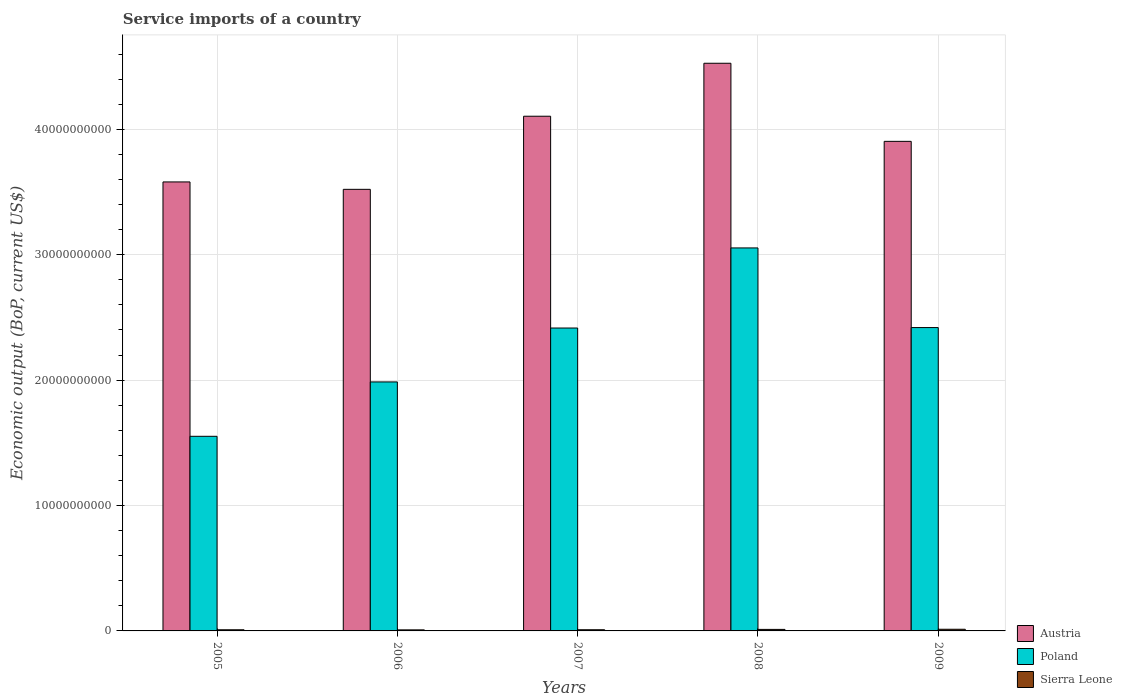How many different coloured bars are there?
Offer a very short reply. 3. How many groups of bars are there?
Ensure brevity in your answer.  5. Are the number of bars per tick equal to the number of legend labels?
Give a very brief answer. Yes. Are the number of bars on each tick of the X-axis equal?
Keep it short and to the point. Yes. In how many cases, is the number of bars for a given year not equal to the number of legend labels?
Ensure brevity in your answer.  0. What is the service imports in Poland in 2006?
Offer a terse response. 1.99e+1. Across all years, what is the maximum service imports in Sierra Leone?
Offer a terse response. 1.32e+08. Across all years, what is the minimum service imports in Sierra Leone?
Your answer should be compact. 8.40e+07. In which year was the service imports in Austria maximum?
Your answer should be compact. 2008. In which year was the service imports in Poland minimum?
Your answer should be compact. 2005. What is the total service imports in Austria in the graph?
Ensure brevity in your answer.  1.96e+11. What is the difference between the service imports in Poland in 2005 and that in 2009?
Provide a short and direct response. -8.67e+09. What is the difference between the service imports in Poland in 2009 and the service imports in Sierra Leone in 2006?
Your answer should be very brief. 2.41e+1. What is the average service imports in Poland per year?
Make the answer very short. 2.29e+1. In the year 2008, what is the difference between the service imports in Sierra Leone and service imports in Poland?
Provide a succinct answer. -3.04e+1. What is the ratio of the service imports in Poland in 2006 to that in 2007?
Offer a very short reply. 0.82. Is the difference between the service imports in Sierra Leone in 2006 and 2009 greater than the difference between the service imports in Poland in 2006 and 2009?
Your answer should be compact. Yes. What is the difference between the highest and the second highest service imports in Sierra Leone?
Make the answer very short. 1.11e+07. What is the difference between the highest and the lowest service imports in Poland?
Your response must be concise. 1.50e+1. In how many years, is the service imports in Poland greater than the average service imports in Poland taken over all years?
Give a very brief answer. 3. What does the 2nd bar from the left in 2005 represents?
Your answer should be compact. Poland. What does the 2nd bar from the right in 2007 represents?
Offer a very short reply. Poland. Is it the case that in every year, the sum of the service imports in Austria and service imports in Sierra Leone is greater than the service imports in Poland?
Your answer should be compact. Yes. How many bars are there?
Give a very brief answer. 15. How many years are there in the graph?
Provide a succinct answer. 5. Are the values on the major ticks of Y-axis written in scientific E-notation?
Offer a terse response. No. Does the graph contain any zero values?
Ensure brevity in your answer.  No. Does the graph contain grids?
Give a very brief answer. Yes. How many legend labels are there?
Ensure brevity in your answer.  3. What is the title of the graph?
Offer a very short reply. Service imports of a country. What is the label or title of the X-axis?
Your answer should be compact. Years. What is the label or title of the Y-axis?
Offer a terse response. Economic output (BoP, current US$). What is the Economic output (BoP, current US$) in Austria in 2005?
Provide a short and direct response. 3.58e+1. What is the Economic output (BoP, current US$) in Poland in 2005?
Your answer should be very brief. 1.55e+1. What is the Economic output (BoP, current US$) of Sierra Leone in 2005?
Your answer should be very brief. 9.14e+07. What is the Economic output (BoP, current US$) of Austria in 2006?
Keep it short and to the point. 3.52e+1. What is the Economic output (BoP, current US$) in Poland in 2006?
Offer a very short reply. 1.99e+1. What is the Economic output (BoP, current US$) of Sierra Leone in 2006?
Provide a succinct answer. 8.40e+07. What is the Economic output (BoP, current US$) of Austria in 2007?
Your answer should be very brief. 4.10e+1. What is the Economic output (BoP, current US$) of Poland in 2007?
Your response must be concise. 2.42e+1. What is the Economic output (BoP, current US$) in Sierra Leone in 2007?
Your answer should be very brief. 9.43e+07. What is the Economic output (BoP, current US$) of Austria in 2008?
Provide a short and direct response. 4.53e+1. What is the Economic output (BoP, current US$) of Poland in 2008?
Ensure brevity in your answer.  3.05e+1. What is the Economic output (BoP, current US$) of Sierra Leone in 2008?
Make the answer very short. 1.21e+08. What is the Economic output (BoP, current US$) of Austria in 2009?
Give a very brief answer. 3.90e+1. What is the Economic output (BoP, current US$) in Poland in 2009?
Offer a very short reply. 2.42e+1. What is the Economic output (BoP, current US$) of Sierra Leone in 2009?
Your answer should be very brief. 1.32e+08. Across all years, what is the maximum Economic output (BoP, current US$) of Austria?
Provide a succinct answer. 4.53e+1. Across all years, what is the maximum Economic output (BoP, current US$) of Poland?
Ensure brevity in your answer.  3.05e+1. Across all years, what is the maximum Economic output (BoP, current US$) of Sierra Leone?
Provide a short and direct response. 1.32e+08. Across all years, what is the minimum Economic output (BoP, current US$) in Austria?
Make the answer very short. 3.52e+1. Across all years, what is the minimum Economic output (BoP, current US$) in Poland?
Offer a terse response. 1.55e+1. Across all years, what is the minimum Economic output (BoP, current US$) in Sierra Leone?
Offer a very short reply. 8.40e+07. What is the total Economic output (BoP, current US$) in Austria in the graph?
Keep it short and to the point. 1.96e+11. What is the total Economic output (BoP, current US$) of Poland in the graph?
Your answer should be compact. 1.14e+11. What is the total Economic output (BoP, current US$) of Sierra Leone in the graph?
Make the answer very short. 5.23e+08. What is the difference between the Economic output (BoP, current US$) of Austria in 2005 and that in 2006?
Offer a terse response. 5.90e+08. What is the difference between the Economic output (BoP, current US$) of Poland in 2005 and that in 2006?
Your answer should be very brief. -4.34e+09. What is the difference between the Economic output (BoP, current US$) of Sierra Leone in 2005 and that in 2006?
Give a very brief answer. 7.37e+06. What is the difference between the Economic output (BoP, current US$) in Austria in 2005 and that in 2007?
Give a very brief answer. -5.24e+09. What is the difference between the Economic output (BoP, current US$) in Poland in 2005 and that in 2007?
Offer a terse response. -8.64e+09. What is the difference between the Economic output (BoP, current US$) in Sierra Leone in 2005 and that in 2007?
Offer a terse response. -2.94e+06. What is the difference between the Economic output (BoP, current US$) in Austria in 2005 and that in 2008?
Your answer should be very brief. -9.46e+09. What is the difference between the Economic output (BoP, current US$) in Poland in 2005 and that in 2008?
Make the answer very short. -1.50e+1. What is the difference between the Economic output (BoP, current US$) in Sierra Leone in 2005 and that in 2008?
Your answer should be very brief. -2.96e+07. What is the difference between the Economic output (BoP, current US$) in Austria in 2005 and that in 2009?
Ensure brevity in your answer.  -3.24e+09. What is the difference between the Economic output (BoP, current US$) of Poland in 2005 and that in 2009?
Ensure brevity in your answer.  -8.67e+09. What is the difference between the Economic output (BoP, current US$) of Sierra Leone in 2005 and that in 2009?
Provide a succinct answer. -4.07e+07. What is the difference between the Economic output (BoP, current US$) in Austria in 2006 and that in 2007?
Provide a short and direct response. -5.83e+09. What is the difference between the Economic output (BoP, current US$) in Poland in 2006 and that in 2007?
Offer a very short reply. -4.30e+09. What is the difference between the Economic output (BoP, current US$) in Sierra Leone in 2006 and that in 2007?
Your answer should be very brief. -1.03e+07. What is the difference between the Economic output (BoP, current US$) of Austria in 2006 and that in 2008?
Provide a succinct answer. -1.01e+1. What is the difference between the Economic output (BoP, current US$) in Poland in 2006 and that in 2008?
Provide a short and direct response. -1.07e+1. What is the difference between the Economic output (BoP, current US$) in Sierra Leone in 2006 and that in 2008?
Provide a short and direct response. -3.70e+07. What is the difference between the Economic output (BoP, current US$) in Austria in 2006 and that in 2009?
Keep it short and to the point. -3.83e+09. What is the difference between the Economic output (BoP, current US$) in Poland in 2006 and that in 2009?
Your answer should be very brief. -4.34e+09. What is the difference between the Economic output (BoP, current US$) of Sierra Leone in 2006 and that in 2009?
Ensure brevity in your answer.  -4.81e+07. What is the difference between the Economic output (BoP, current US$) in Austria in 2007 and that in 2008?
Provide a succinct answer. -4.22e+09. What is the difference between the Economic output (BoP, current US$) of Poland in 2007 and that in 2008?
Ensure brevity in your answer.  -6.39e+09. What is the difference between the Economic output (BoP, current US$) of Sierra Leone in 2007 and that in 2008?
Offer a very short reply. -2.66e+07. What is the difference between the Economic output (BoP, current US$) of Austria in 2007 and that in 2009?
Offer a very short reply. 2.00e+09. What is the difference between the Economic output (BoP, current US$) of Poland in 2007 and that in 2009?
Provide a succinct answer. -3.50e+07. What is the difference between the Economic output (BoP, current US$) of Sierra Leone in 2007 and that in 2009?
Your answer should be very brief. -3.78e+07. What is the difference between the Economic output (BoP, current US$) in Austria in 2008 and that in 2009?
Make the answer very short. 6.23e+09. What is the difference between the Economic output (BoP, current US$) of Poland in 2008 and that in 2009?
Provide a succinct answer. 6.35e+09. What is the difference between the Economic output (BoP, current US$) of Sierra Leone in 2008 and that in 2009?
Provide a short and direct response. -1.11e+07. What is the difference between the Economic output (BoP, current US$) in Austria in 2005 and the Economic output (BoP, current US$) in Poland in 2006?
Your answer should be very brief. 1.59e+1. What is the difference between the Economic output (BoP, current US$) in Austria in 2005 and the Economic output (BoP, current US$) in Sierra Leone in 2006?
Provide a short and direct response. 3.57e+1. What is the difference between the Economic output (BoP, current US$) of Poland in 2005 and the Economic output (BoP, current US$) of Sierra Leone in 2006?
Provide a succinct answer. 1.54e+1. What is the difference between the Economic output (BoP, current US$) of Austria in 2005 and the Economic output (BoP, current US$) of Poland in 2007?
Ensure brevity in your answer.  1.16e+1. What is the difference between the Economic output (BoP, current US$) in Austria in 2005 and the Economic output (BoP, current US$) in Sierra Leone in 2007?
Your response must be concise. 3.57e+1. What is the difference between the Economic output (BoP, current US$) of Poland in 2005 and the Economic output (BoP, current US$) of Sierra Leone in 2007?
Make the answer very short. 1.54e+1. What is the difference between the Economic output (BoP, current US$) of Austria in 2005 and the Economic output (BoP, current US$) of Poland in 2008?
Keep it short and to the point. 5.26e+09. What is the difference between the Economic output (BoP, current US$) of Austria in 2005 and the Economic output (BoP, current US$) of Sierra Leone in 2008?
Provide a succinct answer. 3.57e+1. What is the difference between the Economic output (BoP, current US$) of Poland in 2005 and the Economic output (BoP, current US$) of Sierra Leone in 2008?
Your response must be concise. 1.54e+1. What is the difference between the Economic output (BoP, current US$) in Austria in 2005 and the Economic output (BoP, current US$) in Poland in 2009?
Ensure brevity in your answer.  1.16e+1. What is the difference between the Economic output (BoP, current US$) in Austria in 2005 and the Economic output (BoP, current US$) in Sierra Leone in 2009?
Offer a very short reply. 3.57e+1. What is the difference between the Economic output (BoP, current US$) of Poland in 2005 and the Economic output (BoP, current US$) of Sierra Leone in 2009?
Keep it short and to the point. 1.54e+1. What is the difference between the Economic output (BoP, current US$) of Austria in 2006 and the Economic output (BoP, current US$) of Poland in 2007?
Provide a succinct answer. 1.11e+1. What is the difference between the Economic output (BoP, current US$) of Austria in 2006 and the Economic output (BoP, current US$) of Sierra Leone in 2007?
Offer a terse response. 3.51e+1. What is the difference between the Economic output (BoP, current US$) of Poland in 2006 and the Economic output (BoP, current US$) of Sierra Leone in 2007?
Offer a terse response. 1.98e+1. What is the difference between the Economic output (BoP, current US$) in Austria in 2006 and the Economic output (BoP, current US$) in Poland in 2008?
Offer a very short reply. 4.67e+09. What is the difference between the Economic output (BoP, current US$) of Austria in 2006 and the Economic output (BoP, current US$) of Sierra Leone in 2008?
Your answer should be very brief. 3.51e+1. What is the difference between the Economic output (BoP, current US$) of Poland in 2006 and the Economic output (BoP, current US$) of Sierra Leone in 2008?
Make the answer very short. 1.97e+1. What is the difference between the Economic output (BoP, current US$) in Austria in 2006 and the Economic output (BoP, current US$) in Poland in 2009?
Keep it short and to the point. 1.10e+1. What is the difference between the Economic output (BoP, current US$) in Austria in 2006 and the Economic output (BoP, current US$) in Sierra Leone in 2009?
Offer a terse response. 3.51e+1. What is the difference between the Economic output (BoP, current US$) in Poland in 2006 and the Economic output (BoP, current US$) in Sierra Leone in 2009?
Keep it short and to the point. 1.97e+1. What is the difference between the Economic output (BoP, current US$) in Austria in 2007 and the Economic output (BoP, current US$) in Poland in 2008?
Ensure brevity in your answer.  1.05e+1. What is the difference between the Economic output (BoP, current US$) of Austria in 2007 and the Economic output (BoP, current US$) of Sierra Leone in 2008?
Your response must be concise. 4.09e+1. What is the difference between the Economic output (BoP, current US$) of Poland in 2007 and the Economic output (BoP, current US$) of Sierra Leone in 2008?
Offer a very short reply. 2.40e+1. What is the difference between the Economic output (BoP, current US$) in Austria in 2007 and the Economic output (BoP, current US$) in Poland in 2009?
Make the answer very short. 1.69e+1. What is the difference between the Economic output (BoP, current US$) in Austria in 2007 and the Economic output (BoP, current US$) in Sierra Leone in 2009?
Offer a terse response. 4.09e+1. What is the difference between the Economic output (BoP, current US$) in Poland in 2007 and the Economic output (BoP, current US$) in Sierra Leone in 2009?
Your answer should be very brief. 2.40e+1. What is the difference between the Economic output (BoP, current US$) in Austria in 2008 and the Economic output (BoP, current US$) in Poland in 2009?
Ensure brevity in your answer.  2.11e+1. What is the difference between the Economic output (BoP, current US$) of Austria in 2008 and the Economic output (BoP, current US$) of Sierra Leone in 2009?
Ensure brevity in your answer.  4.51e+1. What is the difference between the Economic output (BoP, current US$) in Poland in 2008 and the Economic output (BoP, current US$) in Sierra Leone in 2009?
Provide a short and direct response. 3.04e+1. What is the average Economic output (BoP, current US$) in Austria per year?
Keep it short and to the point. 3.93e+1. What is the average Economic output (BoP, current US$) in Poland per year?
Provide a succinct answer. 2.29e+1. What is the average Economic output (BoP, current US$) of Sierra Leone per year?
Provide a succinct answer. 1.05e+08. In the year 2005, what is the difference between the Economic output (BoP, current US$) of Austria and Economic output (BoP, current US$) of Poland?
Ensure brevity in your answer.  2.03e+1. In the year 2005, what is the difference between the Economic output (BoP, current US$) in Austria and Economic output (BoP, current US$) in Sierra Leone?
Your answer should be compact. 3.57e+1. In the year 2005, what is the difference between the Economic output (BoP, current US$) in Poland and Economic output (BoP, current US$) in Sierra Leone?
Give a very brief answer. 1.54e+1. In the year 2006, what is the difference between the Economic output (BoP, current US$) in Austria and Economic output (BoP, current US$) in Poland?
Offer a very short reply. 1.54e+1. In the year 2006, what is the difference between the Economic output (BoP, current US$) of Austria and Economic output (BoP, current US$) of Sierra Leone?
Offer a terse response. 3.51e+1. In the year 2006, what is the difference between the Economic output (BoP, current US$) of Poland and Economic output (BoP, current US$) of Sierra Leone?
Your answer should be very brief. 1.98e+1. In the year 2007, what is the difference between the Economic output (BoP, current US$) of Austria and Economic output (BoP, current US$) of Poland?
Provide a succinct answer. 1.69e+1. In the year 2007, what is the difference between the Economic output (BoP, current US$) of Austria and Economic output (BoP, current US$) of Sierra Leone?
Offer a very short reply. 4.10e+1. In the year 2007, what is the difference between the Economic output (BoP, current US$) in Poland and Economic output (BoP, current US$) in Sierra Leone?
Offer a terse response. 2.41e+1. In the year 2008, what is the difference between the Economic output (BoP, current US$) in Austria and Economic output (BoP, current US$) in Poland?
Your response must be concise. 1.47e+1. In the year 2008, what is the difference between the Economic output (BoP, current US$) of Austria and Economic output (BoP, current US$) of Sierra Leone?
Your response must be concise. 4.51e+1. In the year 2008, what is the difference between the Economic output (BoP, current US$) of Poland and Economic output (BoP, current US$) of Sierra Leone?
Offer a very short reply. 3.04e+1. In the year 2009, what is the difference between the Economic output (BoP, current US$) in Austria and Economic output (BoP, current US$) in Poland?
Ensure brevity in your answer.  1.49e+1. In the year 2009, what is the difference between the Economic output (BoP, current US$) of Austria and Economic output (BoP, current US$) of Sierra Leone?
Offer a terse response. 3.89e+1. In the year 2009, what is the difference between the Economic output (BoP, current US$) in Poland and Economic output (BoP, current US$) in Sierra Leone?
Give a very brief answer. 2.41e+1. What is the ratio of the Economic output (BoP, current US$) of Austria in 2005 to that in 2006?
Your answer should be compact. 1.02. What is the ratio of the Economic output (BoP, current US$) of Poland in 2005 to that in 2006?
Make the answer very short. 0.78. What is the ratio of the Economic output (BoP, current US$) of Sierra Leone in 2005 to that in 2006?
Offer a terse response. 1.09. What is the ratio of the Economic output (BoP, current US$) in Austria in 2005 to that in 2007?
Offer a terse response. 0.87. What is the ratio of the Economic output (BoP, current US$) in Poland in 2005 to that in 2007?
Make the answer very short. 0.64. What is the ratio of the Economic output (BoP, current US$) in Sierra Leone in 2005 to that in 2007?
Your answer should be compact. 0.97. What is the ratio of the Economic output (BoP, current US$) of Austria in 2005 to that in 2008?
Ensure brevity in your answer.  0.79. What is the ratio of the Economic output (BoP, current US$) of Poland in 2005 to that in 2008?
Offer a terse response. 0.51. What is the ratio of the Economic output (BoP, current US$) in Sierra Leone in 2005 to that in 2008?
Your answer should be compact. 0.76. What is the ratio of the Economic output (BoP, current US$) of Austria in 2005 to that in 2009?
Offer a very short reply. 0.92. What is the ratio of the Economic output (BoP, current US$) in Poland in 2005 to that in 2009?
Your response must be concise. 0.64. What is the ratio of the Economic output (BoP, current US$) of Sierra Leone in 2005 to that in 2009?
Your answer should be very brief. 0.69. What is the ratio of the Economic output (BoP, current US$) in Austria in 2006 to that in 2007?
Provide a short and direct response. 0.86. What is the ratio of the Economic output (BoP, current US$) of Poland in 2006 to that in 2007?
Your answer should be compact. 0.82. What is the ratio of the Economic output (BoP, current US$) in Sierra Leone in 2006 to that in 2007?
Your answer should be very brief. 0.89. What is the ratio of the Economic output (BoP, current US$) of Austria in 2006 to that in 2008?
Ensure brevity in your answer.  0.78. What is the ratio of the Economic output (BoP, current US$) of Poland in 2006 to that in 2008?
Keep it short and to the point. 0.65. What is the ratio of the Economic output (BoP, current US$) in Sierra Leone in 2006 to that in 2008?
Offer a terse response. 0.69. What is the ratio of the Economic output (BoP, current US$) in Austria in 2006 to that in 2009?
Ensure brevity in your answer.  0.9. What is the ratio of the Economic output (BoP, current US$) of Poland in 2006 to that in 2009?
Keep it short and to the point. 0.82. What is the ratio of the Economic output (BoP, current US$) in Sierra Leone in 2006 to that in 2009?
Provide a short and direct response. 0.64. What is the ratio of the Economic output (BoP, current US$) of Austria in 2007 to that in 2008?
Your response must be concise. 0.91. What is the ratio of the Economic output (BoP, current US$) of Poland in 2007 to that in 2008?
Give a very brief answer. 0.79. What is the ratio of the Economic output (BoP, current US$) of Sierra Leone in 2007 to that in 2008?
Make the answer very short. 0.78. What is the ratio of the Economic output (BoP, current US$) of Austria in 2007 to that in 2009?
Ensure brevity in your answer.  1.05. What is the ratio of the Economic output (BoP, current US$) in Sierra Leone in 2007 to that in 2009?
Offer a very short reply. 0.71. What is the ratio of the Economic output (BoP, current US$) in Austria in 2008 to that in 2009?
Your answer should be very brief. 1.16. What is the ratio of the Economic output (BoP, current US$) in Poland in 2008 to that in 2009?
Give a very brief answer. 1.26. What is the ratio of the Economic output (BoP, current US$) in Sierra Leone in 2008 to that in 2009?
Your answer should be compact. 0.92. What is the difference between the highest and the second highest Economic output (BoP, current US$) in Austria?
Your answer should be compact. 4.22e+09. What is the difference between the highest and the second highest Economic output (BoP, current US$) in Poland?
Make the answer very short. 6.35e+09. What is the difference between the highest and the second highest Economic output (BoP, current US$) of Sierra Leone?
Your answer should be very brief. 1.11e+07. What is the difference between the highest and the lowest Economic output (BoP, current US$) of Austria?
Give a very brief answer. 1.01e+1. What is the difference between the highest and the lowest Economic output (BoP, current US$) in Poland?
Your response must be concise. 1.50e+1. What is the difference between the highest and the lowest Economic output (BoP, current US$) in Sierra Leone?
Provide a short and direct response. 4.81e+07. 